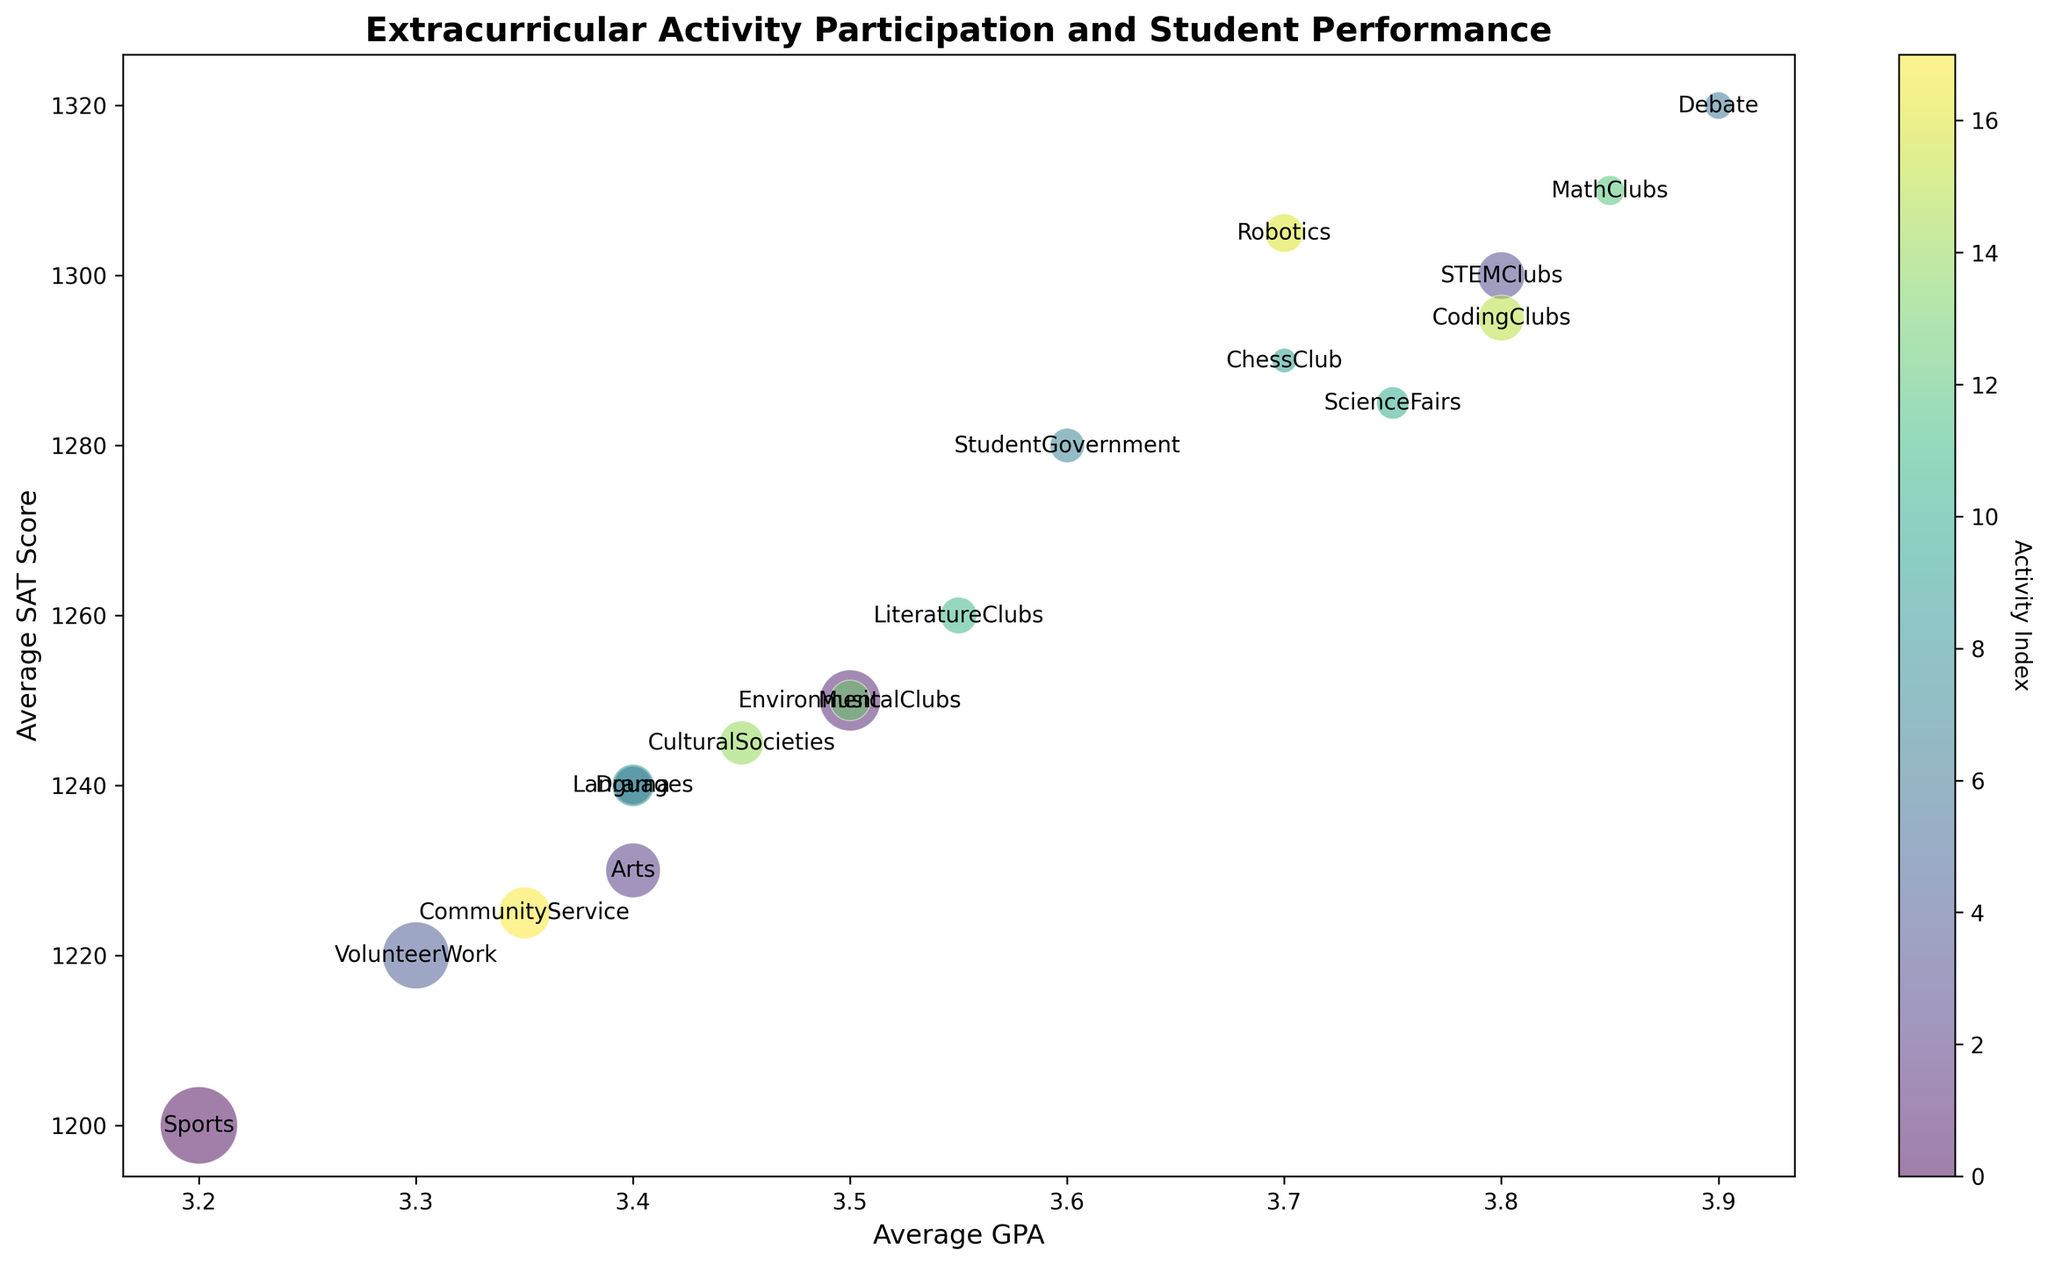Which extracurricular activity has the highest average GPA? By observing the labels and their positions on the x-axis, we locate the activity closest to "Average GPA" 4.0. The highest average GPA activity is closest to the top end of the GPA range.
Answer: Debate What is the participation rate of the activity with the highest average SAT score? First, find the activity with the highest point on the y-axis since SAT scores are represented on the y-axis. Then, check its bubble size, which corresponds to the participation rate.
Answer: 5 Which two activities have the closest average GPAs? By examining the x-axis positions of the bubbles and identifying those closest together horizontally, we can see which activities have similar average GPAs.
Answer: Drama and Languages Which activity is represented by the largest bubble? Observing the sizes of the bubbles on the chart, the largest one corresponds to the highest participation rate.
Answer: Sports Is there a visible correlation between participation rate and student performance? By examining the scatter plot's distribution and noting the bubble positions and sizes relative to the GPA and SAT axes, you can detect if larger bubbles (higher participation) generally align with higher GPAs and SAT scores.
Answer: Yes, a positive trend Which activity has both an average GPA above 3.5 and an average SAT score above 1250? Locate bubbles that align above 3.5 on the x-axis and 1250 on the y-axis. Check the activity labels for these conditions.
Answer: StudentGovernment What average SAT score is associated with the activity that has a participation rate of 10%? Find the bubbles that visually represent a participation rate close to 10% by their size, then check the y-axis value where their center is located.
Answer: 1240 Which activities have higher participation rates than all STEM-related clubs combined? Sum the participation rates of STEMClubs, MathClubs, and CodingClubs, and compare each bubble to check which have rates higher than this total.
Answer: Sports What's the average GPA difference between STEMClubs and MathClubs? Identify the GPA values for STEMClubs and MathClubs, then subtract one from the other to find the difference.
Answer: 0.05 Which activities have a similar average SAT score but varying participation rates? Compare the y-axis positions of different bubbles to find groups that align closely vertically but have different bubble sizes. Pay attention to the range of overlaps.
Answer: Arts, Music, Environmental Clubs 